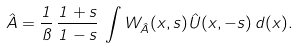<formula> <loc_0><loc_0><loc_500><loc_500>\hat { A } = \frac { 1 } { \pi } \, \frac { 1 + s } { 1 - s } \, \int W _ { \hat { A } } ( { x } , s ) \hat { U } ( { x } , - s ) \, d ( { x } ) .</formula> 